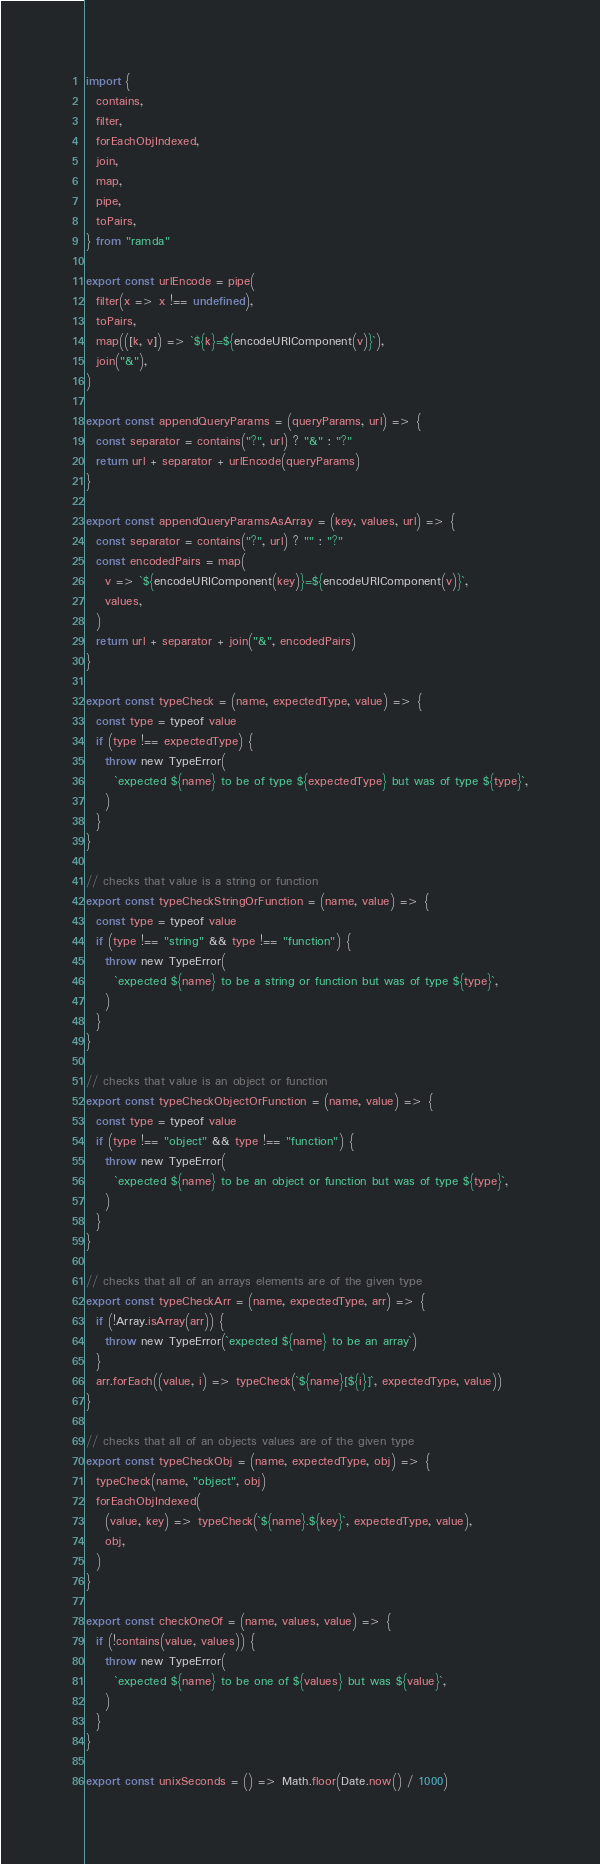<code> <loc_0><loc_0><loc_500><loc_500><_JavaScript_>import {
  contains,
  filter,
  forEachObjIndexed,
  join,
  map,
  pipe,
  toPairs,
} from "ramda"

export const urlEncode = pipe(
  filter(x => x !== undefined),
  toPairs,
  map(([k, v]) => `${k}=${encodeURIComponent(v)}`),
  join("&"),
)

export const appendQueryParams = (queryParams, url) => {
  const separator = contains("?", url) ? "&" : "?"
  return url + separator + urlEncode(queryParams)
}

export const appendQueryParamsAsArray = (key, values, url) => {
  const separator = contains("?", url) ? "" : "?"
  const encodedPairs = map(
    v => `${encodeURIComponent(key)}=${encodeURIComponent(v)}`,
    values,
  )
  return url + separator + join("&", encodedPairs)
}

export const typeCheck = (name, expectedType, value) => {
  const type = typeof value
  if (type !== expectedType) {
    throw new TypeError(
      `expected ${name} to be of type ${expectedType} but was of type ${type}`,
    )
  }
}

// checks that value is a string or function
export const typeCheckStringOrFunction = (name, value) => {
  const type = typeof value
  if (type !== "string" && type !== "function") {
    throw new TypeError(
      `expected ${name} to be a string or function but was of type ${type}`,
    )
  }
}

// checks that value is an object or function
export const typeCheckObjectOrFunction = (name, value) => {
  const type = typeof value
  if (type !== "object" && type !== "function") {
    throw new TypeError(
      `expected ${name} to be an object or function but was of type ${type}`,
    )
  }
}

// checks that all of an arrays elements are of the given type
export const typeCheckArr = (name, expectedType, arr) => {
  if (!Array.isArray(arr)) {
    throw new TypeError(`expected ${name} to be an array`)
  }
  arr.forEach((value, i) => typeCheck(`${name}[${i}]`, expectedType, value))
}

// checks that all of an objects values are of the given type
export const typeCheckObj = (name, expectedType, obj) => {
  typeCheck(name, "object", obj)
  forEachObjIndexed(
    (value, key) => typeCheck(`${name}.${key}`, expectedType, value),
    obj,
  )
}

export const checkOneOf = (name, values, value) => {
  if (!contains(value, values)) {
    throw new TypeError(
      `expected ${name} to be one of ${values} but was ${value}`,
    )
  }
}

export const unixSeconds = () => Math.floor(Date.now() / 1000)
</code> 